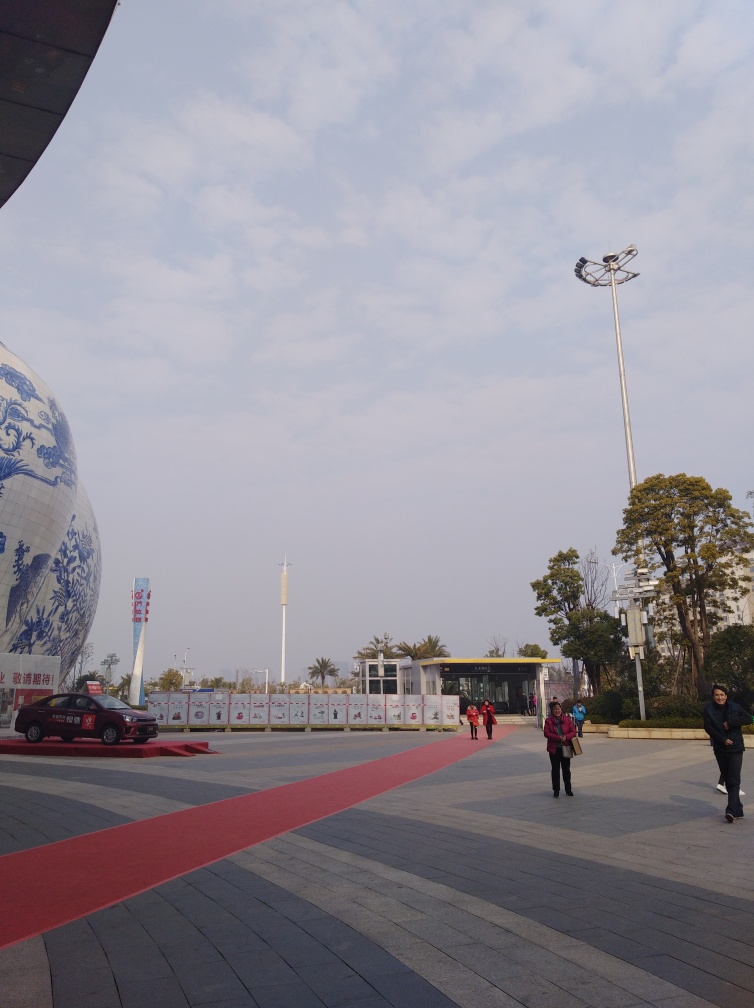How does the red carpet in the photo possibly influence the experience of the place? The red carpet creates a visual pathway leading toward the building, perhaps indicating an entrance or a path of importance. It adds a formal, almost ceremonial quality to the surroundings, making the area more welcoming and guiding visitors along a designated route. 